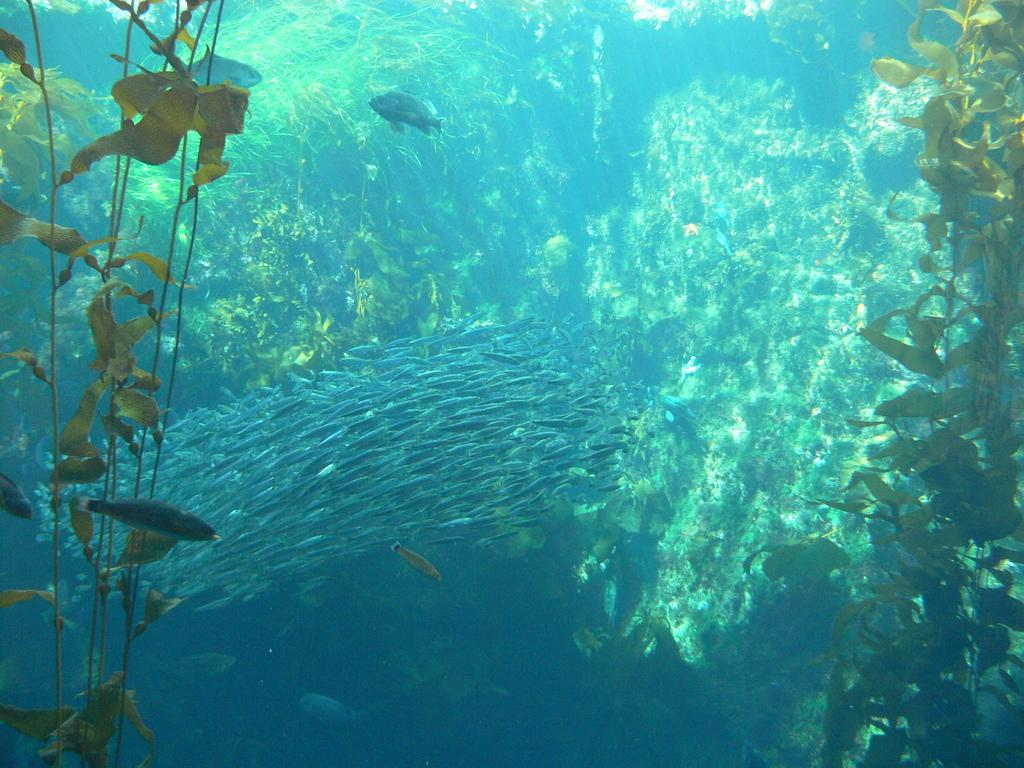What type of animals can be seen in the image? There are fishes in the image. What other living organisms are present in the image? There are plants in the image. Where are the fishes and plants located? Both the fishes and plants are in the water. What scent is being emitted by the secretary in the image? There is no secretary present in the image, so it is not possible to determine any scent being emitted. 